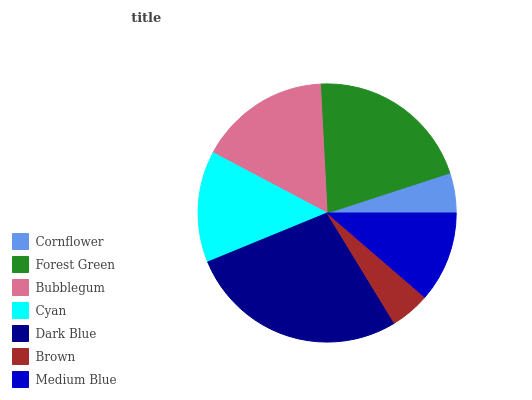Is Brown the minimum?
Answer yes or no. Yes. Is Dark Blue the maximum?
Answer yes or no. Yes. Is Forest Green the minimum?
Answer yes or no. No. Is Forest Green the maximum?
Answer yes or no. No. Is Forest Green greater than Cornflower?
Answer yes or no. Yes. Is Cornflower less than Forest Green?
Answer yes or no. Yes. Is Cornflower greater than Forest Green?
Answer yes or no. No. Is Forest Green less than Cornflower?
Answer yes or no. No. Is Cyan the high median?
Answer yes or no. Yes. Is Cyan the low median?
Answer yes or no. Yes. Is Forest Green the high median?
Answer yes or no. No. Is Dark Blue the low median?
Answer yes or no. No. 